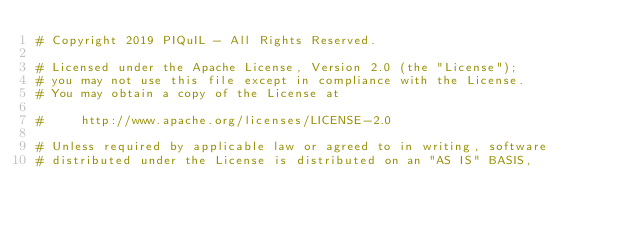<code> <loc_0><loc_0><loc_500><loc_500><_Python_># Copyright 2019 PIQuIL - All Rights Reserved.

# Licensed under the Apache License, Version 2.0 (the "License");
# you may not use this file except in compliance with the License.
# You may obtain a copy of the License at

#     http://www.apache.org/licenses/LICENSE-2.0

# Unless required by applicable law or agreed to in writing, software
# distributed under the License is distributed on an "AS IS" BASIS,</code> 